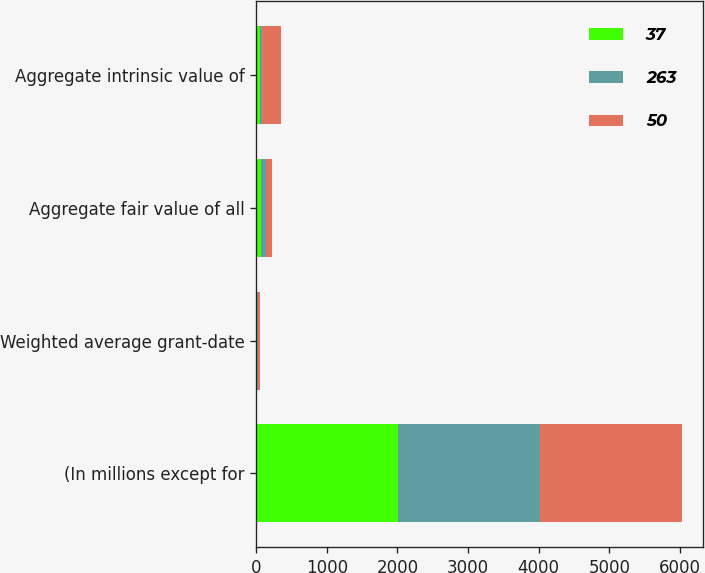<chart> <loc_0><loc_0><loc_500><loc_500><stacked_bar_chart><ecel><fcel>(In millions except for<fcel>Weighted average grant-date<fcel>Aggregate fair value of all<fcel>Aggregate intrinsic value of<nl><fcel>37<fcel>2010<fcel>14.05<fcel>71<fcel>50<nl><fcel>263<fcel>2009<fcel>14.91<fcel>72<fcel>37<nl><fcel>50<fcel>2008<fcel>19.31<fcel>78<fcel>263<nl></chart> 